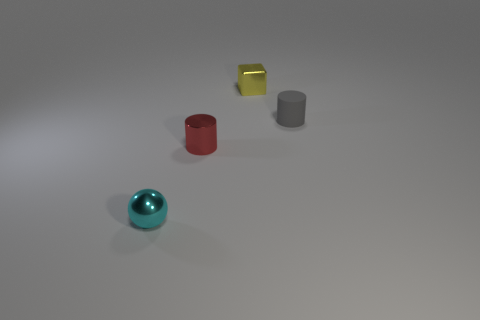How many things are either metal objects that are behind the small metal sphere or cyan objects?
Your answer should be very brief. 3. What number of other objects are the same size as the gray thing?
Offer a terse response. 3. What is the cylinder that is left of the tiny metallic object behind the cylinder behind the tiny shiny cylinder made of?
Offer a very short reply. Metal. What number of blocks are tiny cyan objects or yellow matte objects?
Provide a succinct answer. 0. Are there any other things that have the same shape as the small red object?
Give a very brief answer. Yes. Are there more tiny metallic cylinders that are on the left side of the cyan shiny ball than cubes that are in front of the gray cylinder?
Your answer should be very brief. No. How many metal cylinders are on the left side of the cylinder behind the small red metal thing?
Offer a terse response. 1. How many objects are small yellow cylinders or blocks?
Provide a succinct answer. 1. Does the gray object have the same shape as the small red metallic thing?
Give a very brief answer. Yes. What is the material of the tiny sphere?
Provide a short and direct response. Metal. 